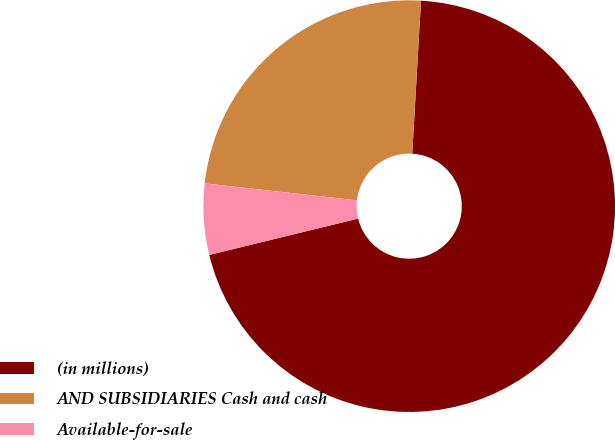Convert chart. <chart><loc_0><loc_0><loc_500><loc_500><pie_chart><fcel>(in millions)<fcel>AND SUBSIDIARIES Cash and cash<fcel>Available-for-sale<nl><fcel>70.28%<fcel>24.15%<fcel>5.57%<nl></chart> 